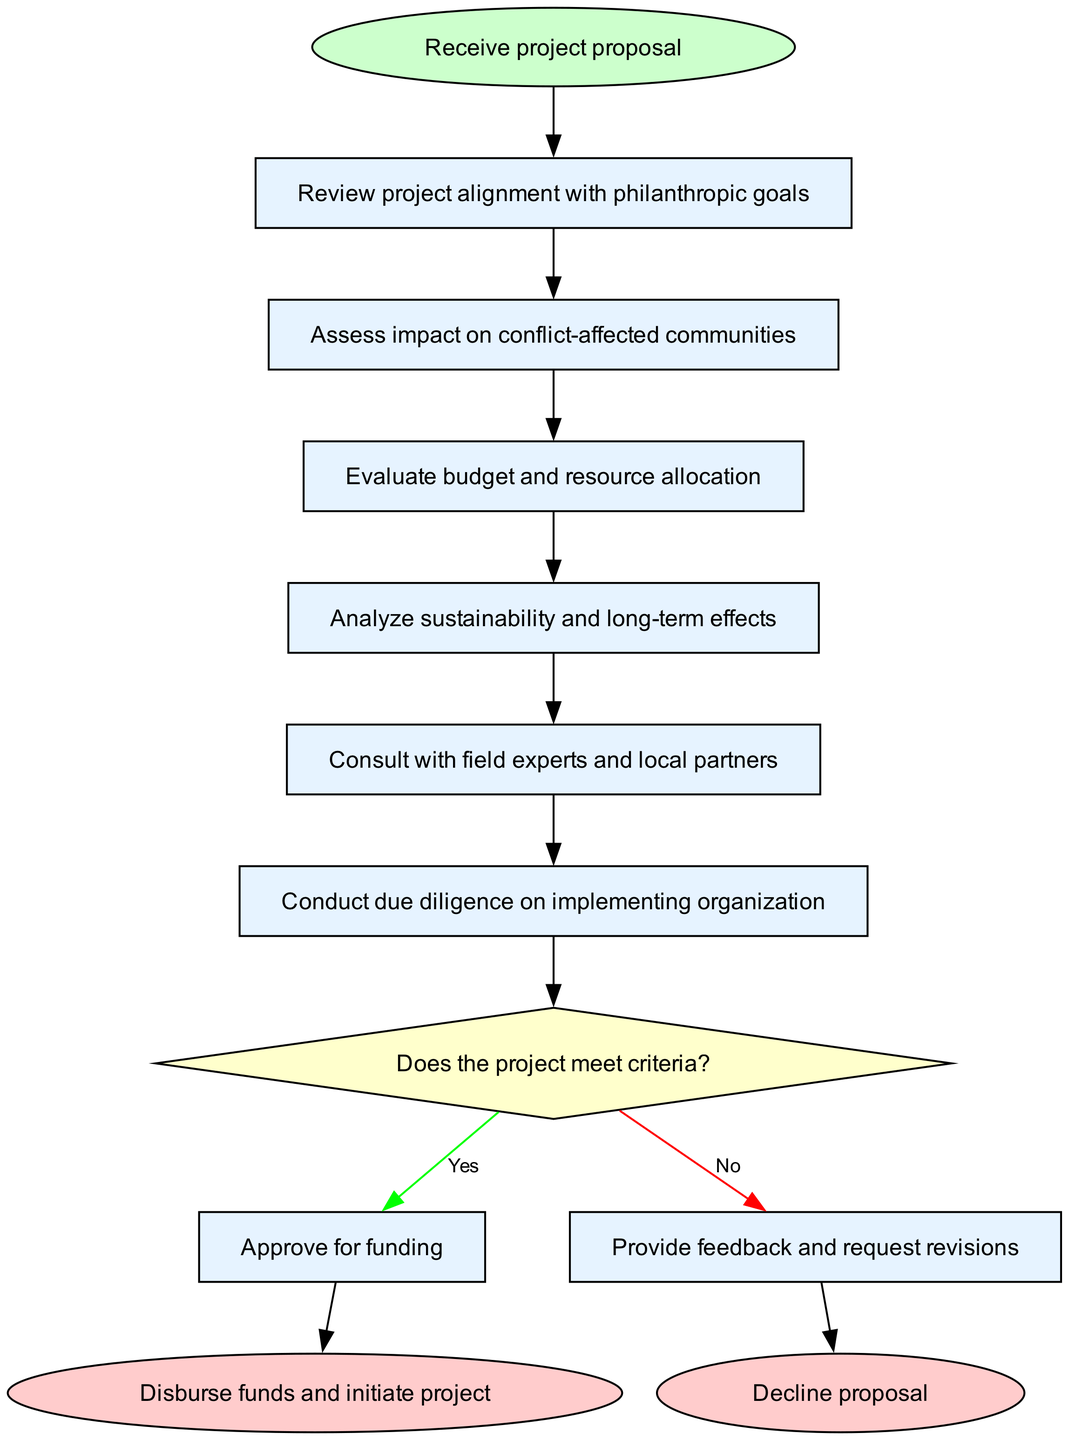What is the first step in the project proposal evaluation process? The diagram indicates that the first step is to "Receive project proposal". This is represented by the start node in the flow chart.
Answer: Receive project proposal How many processes are there in the evaluation process? By counting the items listed in the "processes" section of the diagram, there are a total of six processes.
Answer: Six What are the two possible outcomes of the decision node? The decision node presents two possible outcomes: "Approve for funding" and "Provide feedback and request revisions". These outcomes are directly linked to the yes/no paths from the decision.
Answer: Approve for funding and Provide feedback and request revisions What step follows after assessing impact on conflict-affected communities? The diagram shows that the step that follows after "Assess impact on conflict-affected communities" is "Evaluate budget and resource allocation". This can be traced through the sequence of process nodes.
Answer: Evaluate budget and resource allocation If the project does not meet criteria, what action is taken according to the diagram? If the project does not meet criteria, the outcome is to "Provide feedback and request revisions", as indicated in the decision paths of the diagram.
Answer: Provide feedback and request revisions Which decision leads to the disbursement of funds? The decision that leads to the disbursement of funds is the "Yes" outcome from the decision node, which results in the "Disburse funds and initiate project".
Answer: Yes What color represents the process nodes in the flowchart? The process nodes in the flowchart are represented by a light blue fill color (#E6F3FF) as indicated in the node style definitions within the diagram.
Answer: Light blue What is the shape of the start node in the diagram? The start node is shaped as an oval, which is standard for representing a start point in a flow chart. This shape is specified in the node attributes for the start node.
Answer: Oval 